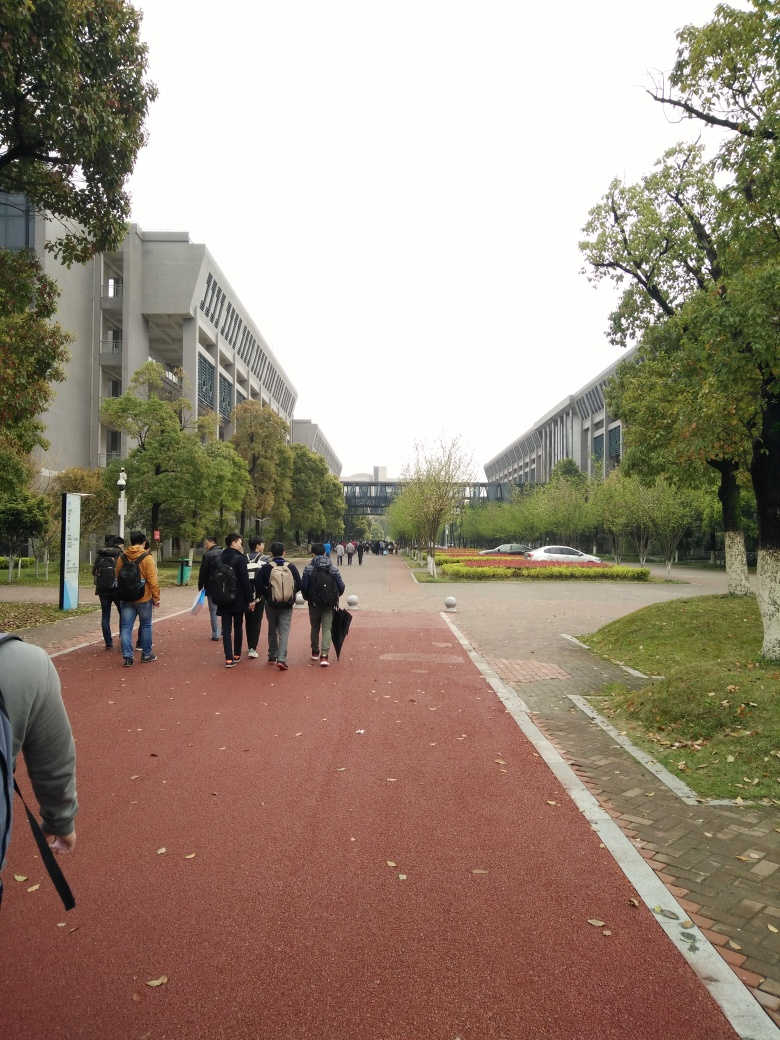What kind of activities might take place here? This pathway could serve as a bustling thoroughfare during peak hours, with students and faculty walking or cycling to classes or meetings. The ample space adjacent to the pathway may also be used for outdoor events, study groups, or leisure activities such as picnics on sunny days. Additionally, the red running track adjacent to the path suggests that physical exercise and sports activities could be common in this area. Could you infer anything about the climate or season? The overcast sky and the attire of the people suggest a cooler climate or a transitional season like autumn or spring. The presence of both green-leaved and bare-branched trees indicates that it might be early autumn when the leaves are just beginning to fall, or late spring when some trees are still budding. 